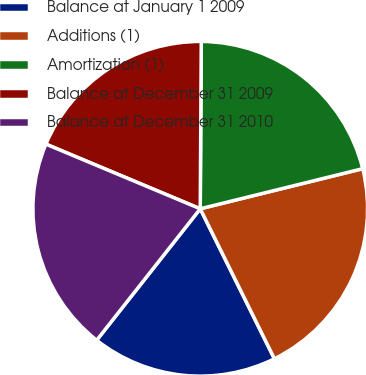Convert chart. <chart><loc_0><loc_0><loc_500><loc_500><pie_chart><fcel>Balance at January 1 2009<fcel>Additions (1)<fcel>Amortization (1)<fcel>Balance at December 31 2009<fcel>Balance at December 31 2010<nl><fcel>17.93%<fcel>21.54%<fcel>21.05%<fcel>18.78%<fcel>20.69%<nl></chart> 